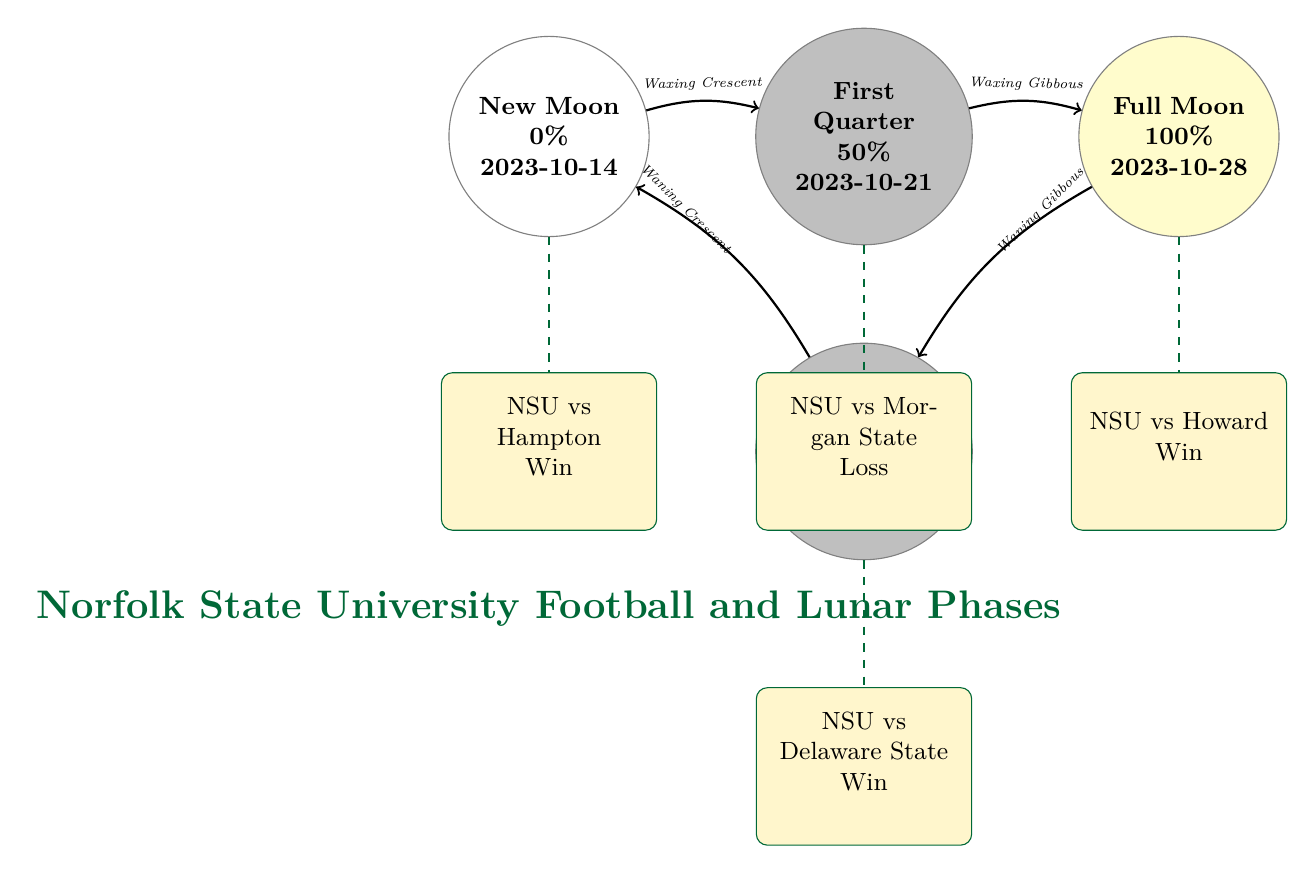What are the phases of the Moon shown in the diagram? The diagram shows four phases of the Moon: New Moon, First Quarter, Full Moon, and Last Quarter. Each phase is labeled in the corresponding moon shapes presented visually.
Answer: New Moon, First Quarter, Full Moon, Last Quarter What is the outcome of the game on the Full Moon date? The game on the Full Moon date (2023-10-28) is between NSU and Howard, and it is noted as a Win. This information comes directly from the game details provided under the Full Moon node.
Answer: Win How many games are highlighted in the diagram? The diagram presents four games that correspond to the lunar phases. Each game is associated with one of the phases, and they are clearly displayed under each moon phase.
Answer: Four Which lunar phase corresponds with the game against Hampton? The game against Hampton (Win) is associated with the New Moon phase (2023-10-14). The game is placed directly below the New Moon node in the diagram.
Answer: New Moon What percentage of luminosity is associated with the Last Quarter phase? The Last Quarter phase is associated with a luminosity of 50%. This value is stated in the node corresponding to that phase.
Answer: 50% What was the outcome of the game against Morgan State? The game against Morgan State is noted as a Loss. This information is directly visible beneath the First Quarter node, outlining the game details.
Answer: Loss What is the date of the game that corresponds to the Last Quarter phase? The game corresponding to the Last Quarter phase takes place on 2023-11-05. This date can be found directly below the Last Quarter node in the diagram.
Answer: 2023-11-05 Which phase has the highest luminosity percentage shown in the diagram? The Full Moon phase has the highest luminosity percentage of 100%. This value is explicitly indicated in the Full Moon node within the diagram.
Answer: 100% 